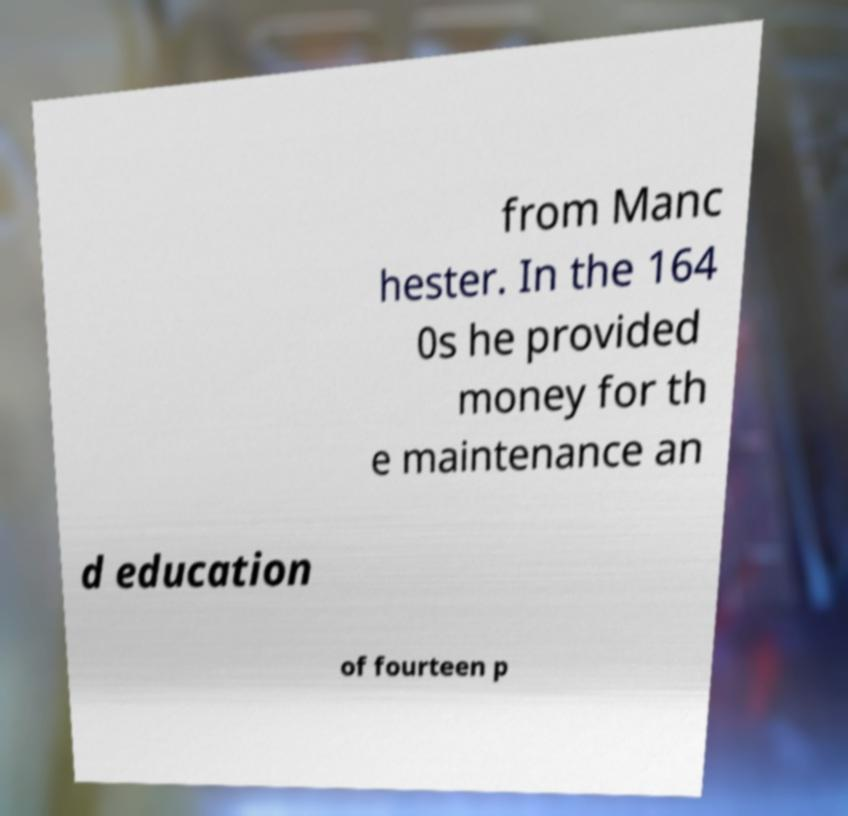There's text embedded in this image that I need extracted. Can you transcribe it verbatim? from Manc hester. In the 164 0s he provided money for th e maintenance an d education of fourteen p 